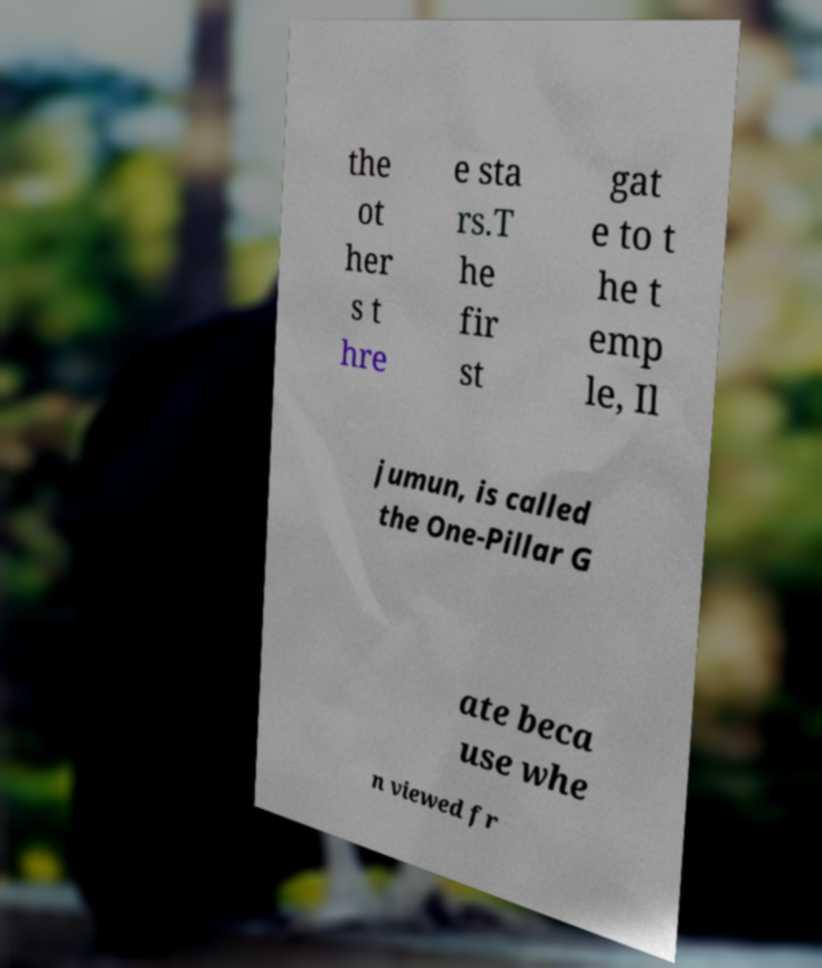Can you read and provide the text displayed in the image?This photo seems to have some interesting text. Can you extract and type it out for me? the ot her s t hre e sta rs.T he fir st gat e to t he t emp le, Il jumun, is called the One-Pillar G ate beca use whe n viewed fr 